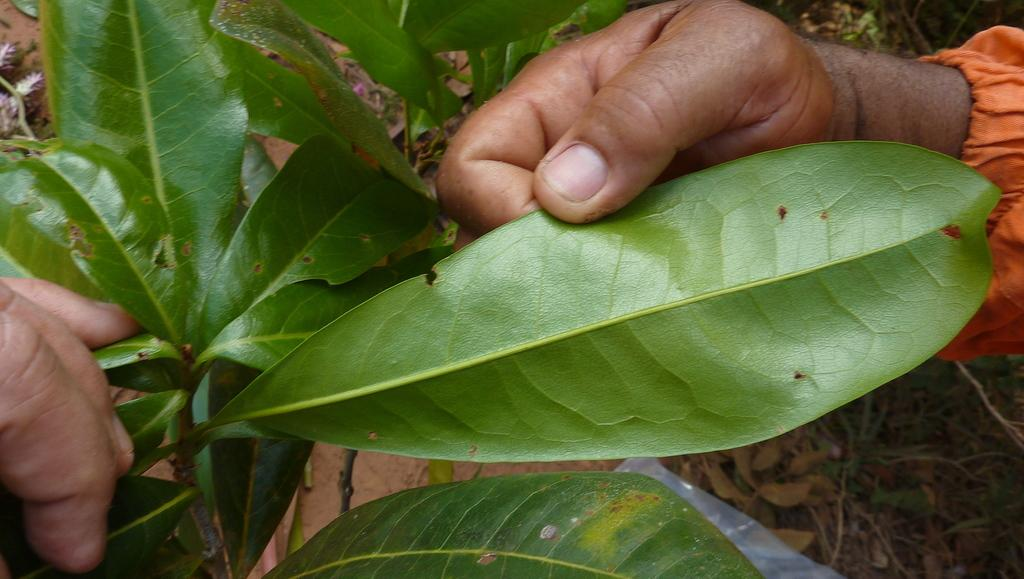What is the person doing in the image? The person's hands are holding the leaves of a plant in the image. What can be seen at the bottom right of the image? The ground is visible at the bottom right of the image. How does the person rub the gate in the image? There is no gate present in the image, so the person cannot rub a gate. 